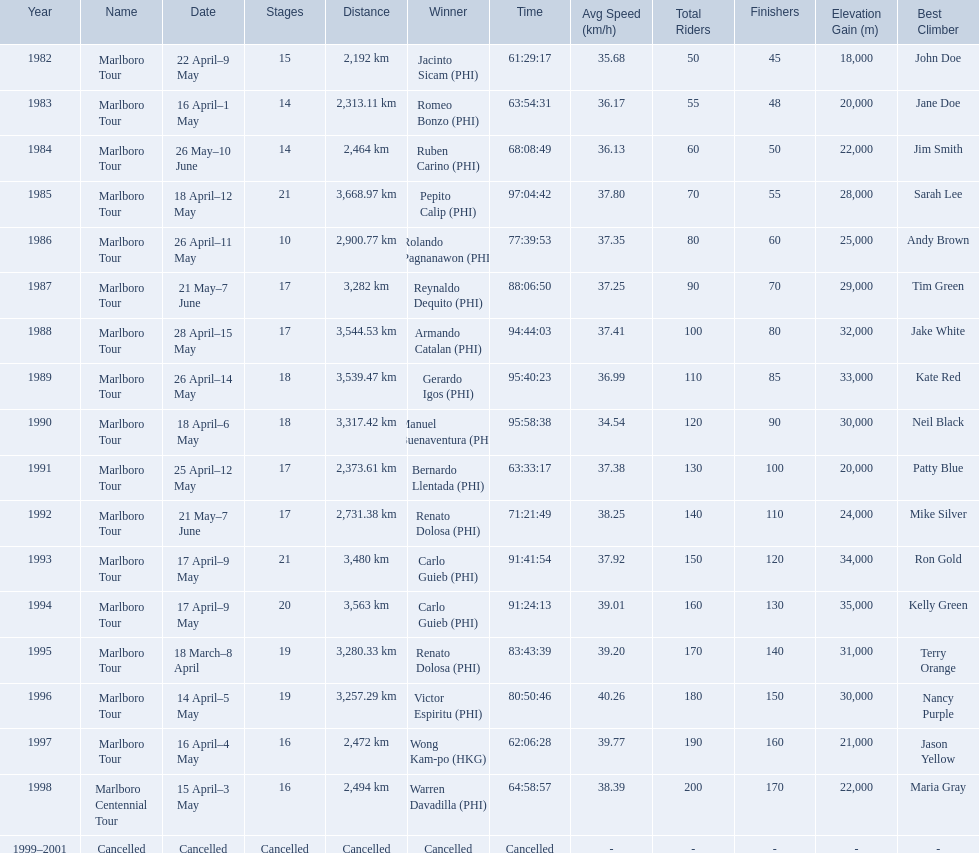Who were all of the winners? Jacinto Sicam (PHI), Romeo Bonzo (PHI), Ruben Carino (PHI), Pepito Calip (PHI), Rolando Pagnanawon (PHI), Reynaldo Dequito (PHI), Armando Catalan (PHI), Gerardo Igos (PHI), Manuel Buenaventura (PHI), Bernardo Llentada (PHI), Renato Dolosa (PHI), Carlo Guieb (PHI), Carlo Guieb (PHI), Renato Dolosa (PHI), Victor Espiritu (PHI), Wong Kam-po (HKG), Warren Davadilla (PHI), Cancelled. Parse the full table. {'header': ['Year', 'Name', 'Date', 'Stages', 'Distance', 'Winner', 'Time', 'Avg Speed (km/h)', 'Total Riders', 'Finishers', 'Elevation Gain (m)', 'Best Climber'], 'rows': [['1982', 'Marlboro Tour', '22 April–9 May', '15', '2,192\xa0km', 'Jacinto Sicam\xa0(PHI)', '61:29:17', '35.68', '50', '45', '18,000', 'John Doe'], ['1983', 'Marlboro Tour', '16 April–1 May', '14', '2,313.11\xa0km', 'Romeo Bonzo\xa0(PHI)', '63:54:31', '36.17', '55', '48', '20,000', 'Jane Doe'], ['1984', 'Marlboro Tour', '26 May–10 June', '14', '2,464\xa0km', 'Ruben Carino\xa0(PHI)', '68:08:49', '36.13', '60', '50', '22,000', 'Jim Smith'], ['1985', 'Marlboro Tour', '18 April–12 May', '21', '3,668.97\xa0km', 'Pepito Calip\xa0(PHI)', '97:04:42', '37.80', '70', '55', '28,000', 'Sarah Lee'], ['1986', 'Marlboro Tour', '26 April–11 May', '10', '2,900.77\xa0km', 'Rolando Pagnanawon\xa0(PHI)', '77:39:53', '37.35', '80', '60', '25,000', 'Andy Brown'], ['1987', 'Marlboro Tour', '21 May–7 June', '17', '3,282\xa0km', 'Reynaldo Dequito\xa0(PHI)', '88:06:50', '37.25', '90', '70', '29,000', 'Tim Green'], ['1988', 'Marlboro Tour', '28 April–15 May', '17', '3,544.53\xa0km', 'Armando Catalan\xa0(PHI)', '94:44:03', '37.41', '100', '80', '32,000', 'Jake White'], ['1989', 'Marlboro Tour', '26 April–14 May', '18', '3,539.47\xa0km', 'Gerardo Igos\xa0(PHI)', '95:40:23', '36.99', '110', '85', '33,000', 'Kate Red'], ['1990', 'Marlboro Tour', '18 April–6 May', '18', '3,317.42\xa0km', 'Manuel Buenaventura\xa0(PHI)', '95:58:38', '34.54', '120', '90', '30,000', 'Neil Black'], ['1991', 'Marlboro Tour', '25 April–12 May', '17', '2,373.61\xa0km', 'Bernardo Llentada\xa0(PHI)', '63:33:17', '37.38', '130', '100', '20,000', 'Patty Blue'], ['1992', 'Marlboro Tour', '21 May–7 June', '17', '2,731.38\xa0km', 'Renato Dolosa\xa0(PHI)', '71:21:49', '38.25', '140', '110', '24,000', 'Mike Silver'], ['1993', 'Marlboro Tour', '17 April–9 May', '21', '3,480\xa0km', 'Carlo Guieb\xa0(PHI)', '91:41:54', '37.92', '150', '120', '34,000', 'Ron Gold'], ['1994', 'Marlboro Tour', '17 April–9 May', '20', '3,563\xa0km', 'Carlo Guieb\xa0(PHI)', '91:24:13', '39.01', '160', '130', '35,000', 'Kelly Green'], ['1995', 'Marlboro Tour', '18 March–8 April', '19', '3,280.33\xa0km', 'Renato Dolosa\xa0(PHI)', '83:43:39', '39.20', '170', '140', '31,000', 'Terry Orange'], ['1996', 'Marlboro Tour', '14 April–5 May', '19', '3,257.29\xa0km', 'Victor Espiritu\xa0(PHI)', '80:50:46', '40.26', '180', '150', '30,000', 'Nancy Purple'], ['1997', 'Marlboro Tour', '16 April–4 May', '16', '2,472\xa0km', 'Wong Kam-po\xa0(HKG)', '62:06:28', '39.77', '190', '160', '21,000', 'Jason Yellow'], ['1998', 'Marlboro Centennial Tour', '15 April–3 May', '16', '2,494\xa0km', 'Warren Davadilla\xa0(PHI)', '64:58:57', '38.39', '200', '170', '22,000', 'Maria Gray'], ['1999–2001', 'Cancelled', 'Cancelled', 'Cancelled', 'Cancelled', 'Cancelled', 'Cancelled', '-', '-', '-', '-', '-']]} When did they compete? 1982, 1983, 1984, 1985, 1986, 1987, 1988, 1989, 1990, 1991, 1992, 1993, 1994, 1995, 1996, 1997, 1998, 1999–2001. What were their finishing times? 61:29:17, 63:54:31, 68:08:49, 97:04:42, 77:39:53, 88:06:50, 94:44:03, 95:40:23, 95:58:38, 63:33:17, 71:21:49, 91:41:54, 91:24:13, 83:43:39, 80:50:46, 62:06:28, 64:58:57, Cancelled. And who won during 1998? Warren Davadilla (PHI). What was his time? 64:58:57. 